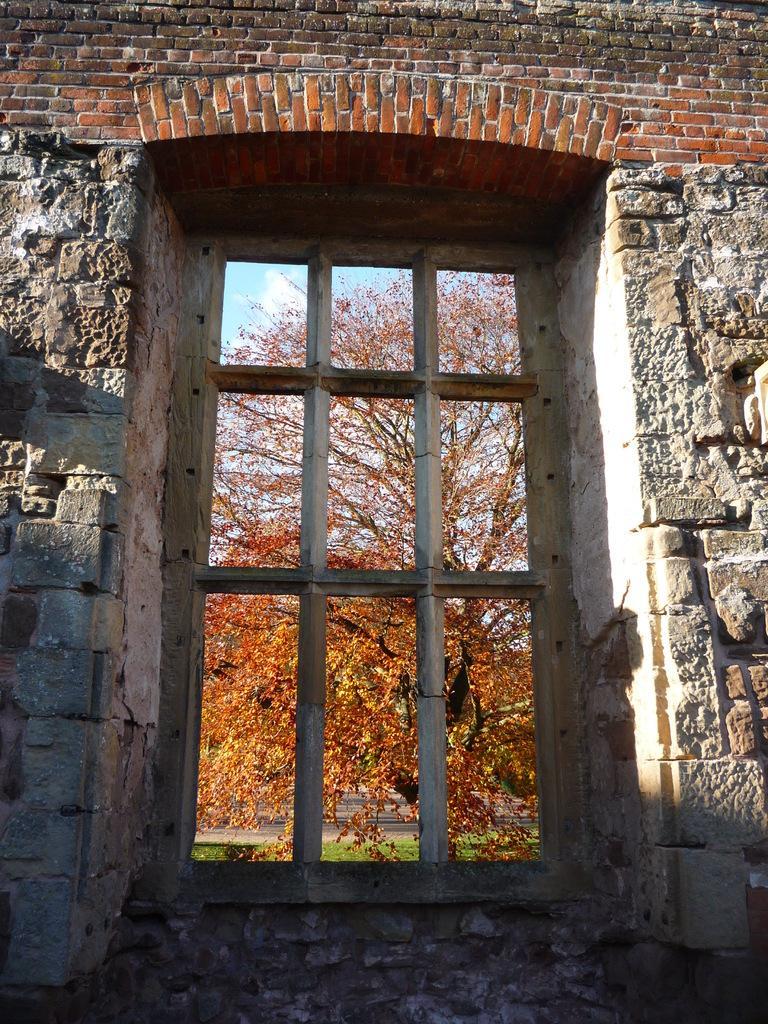Describe this image in one or two sentences. In this picture we can see the wall. Through the window we can see a tree and green grass at the bottom. 